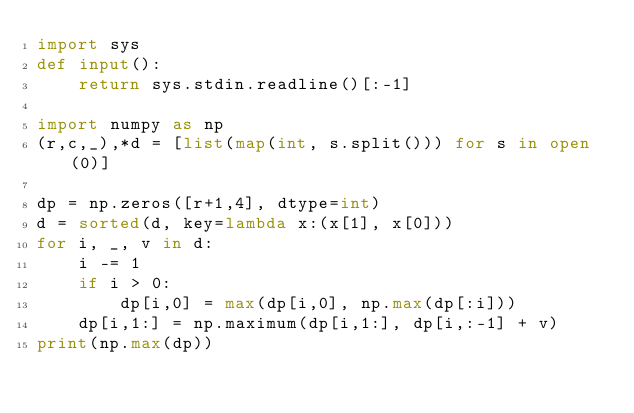<code> <loc_0><loc_0><loc_500><loc_500><_Python_>import sys
def input():
    return sys.stdin.readline()[:-1]

import numpy as np
(r,c,_),*d = [list(map(int, s.split())) for s in open(0)]

dp = np.zeros([r+1,4], dtype=int)
d = sorted(d, key=lambda x:(x[1], x[0]))
for i, _, v in d:
    i -= 1
    if i > 0:
        dp[i,0] = max(dp[i,0], np.max(dp[:i]))
    dp[i,1:] = np.maximum(dp[i,1:], dp[i,:-1] + v)
print(np.max(dp))</code> 